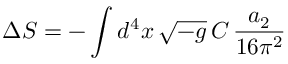Convert formula to latex. <formula><loc_0><loc_0><loc_500><loc_500>\Delta S = - \int d ^ { 4 } x \, \sqrt { - g } \, C \, \frac { a _ { 2 } } { 1 6 \pi ^ { 2 } }</formula> 